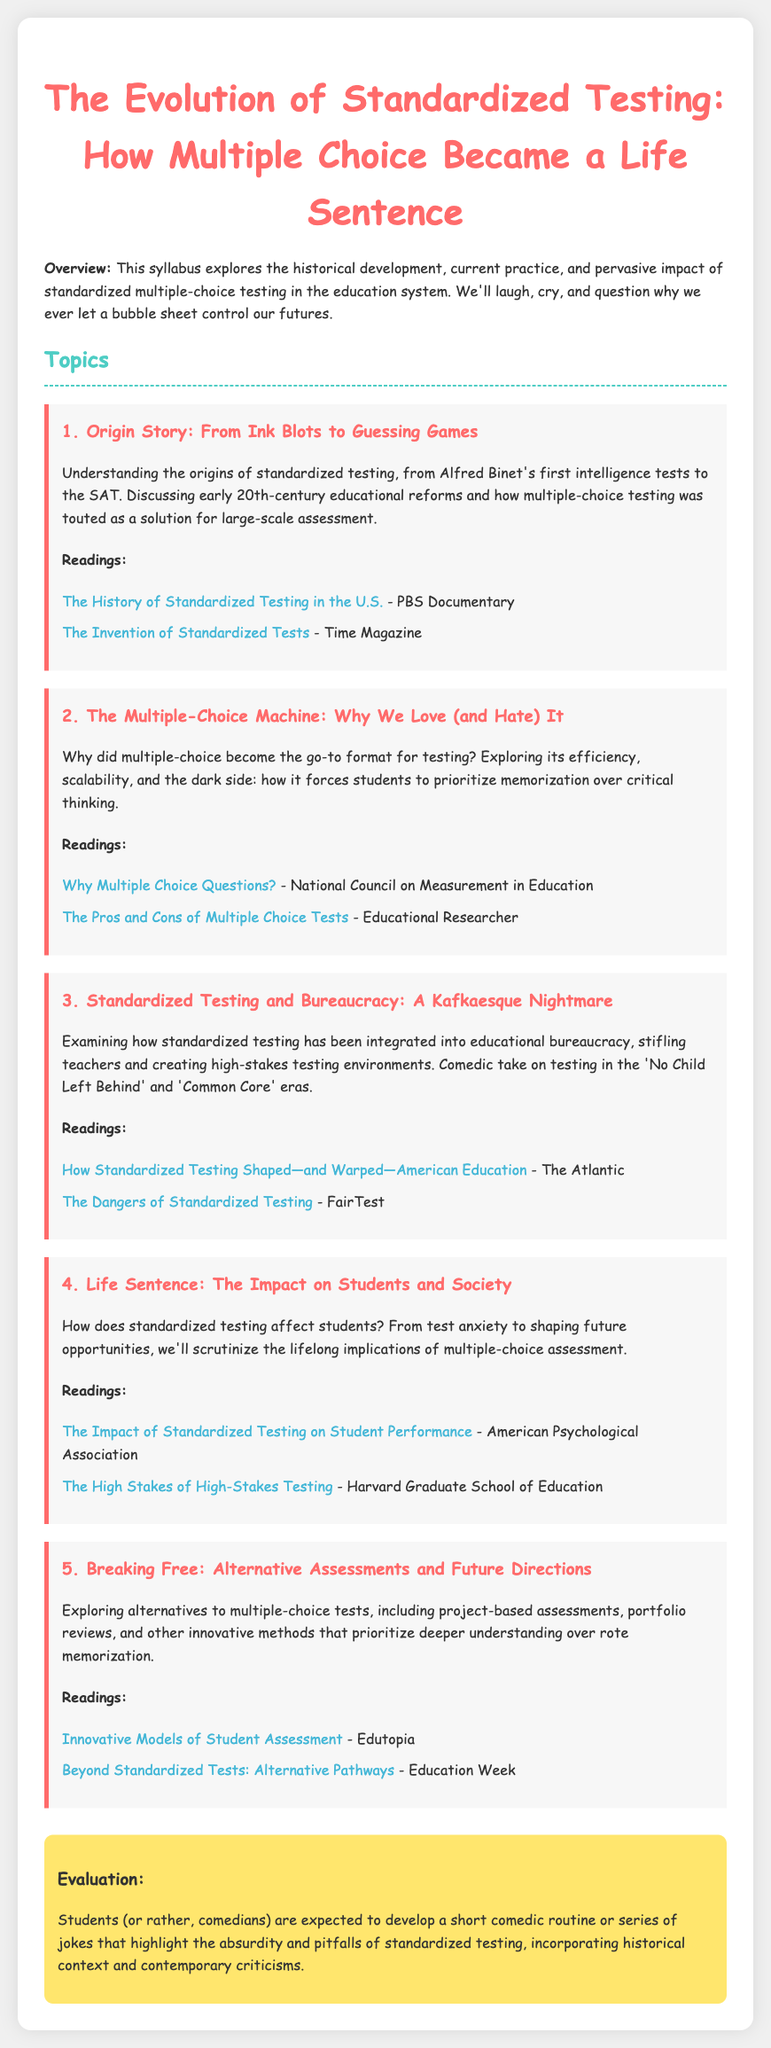What is the title of the syllabus? The title of the syllabus is mentioned at the beginning of the document.
Answer: The Evolution of Standardized Testing: How Multiple Choice Became a Life Sentence What is the first topic covered in the syllabus? The first topic is listed in the Topics section of the document.
Answer: Origin Story: From Ink Blots to Guessing Games How many readings are listed under the second topic? The number of readings can be counted from the readings section under the second topic.
Answer: 2 What type of testing is primarily discussed in the syllabus? The syllabus highlights the format of testing throughout the document.
Answer: Multiple-choice Which educational reforms are mentioned in connection with standardized testing? The document discusses early 20th-century educational reforms in the first topic.
Answer: Early 20th-century educational reforms What is the evaluation method suggested for students? The evaluation section describes what is expected from students at the end of the syllabus.
Answer: Develop a short comedic routine What is the background color of the document body? The background color is specified within the CSS styling in the document.
Answer: #f0f0f0 Who published an article on the dangers of standardized testing? The source of the reading about the dangers is explicitly mentioned in the third topic.
Answer: FairTest 